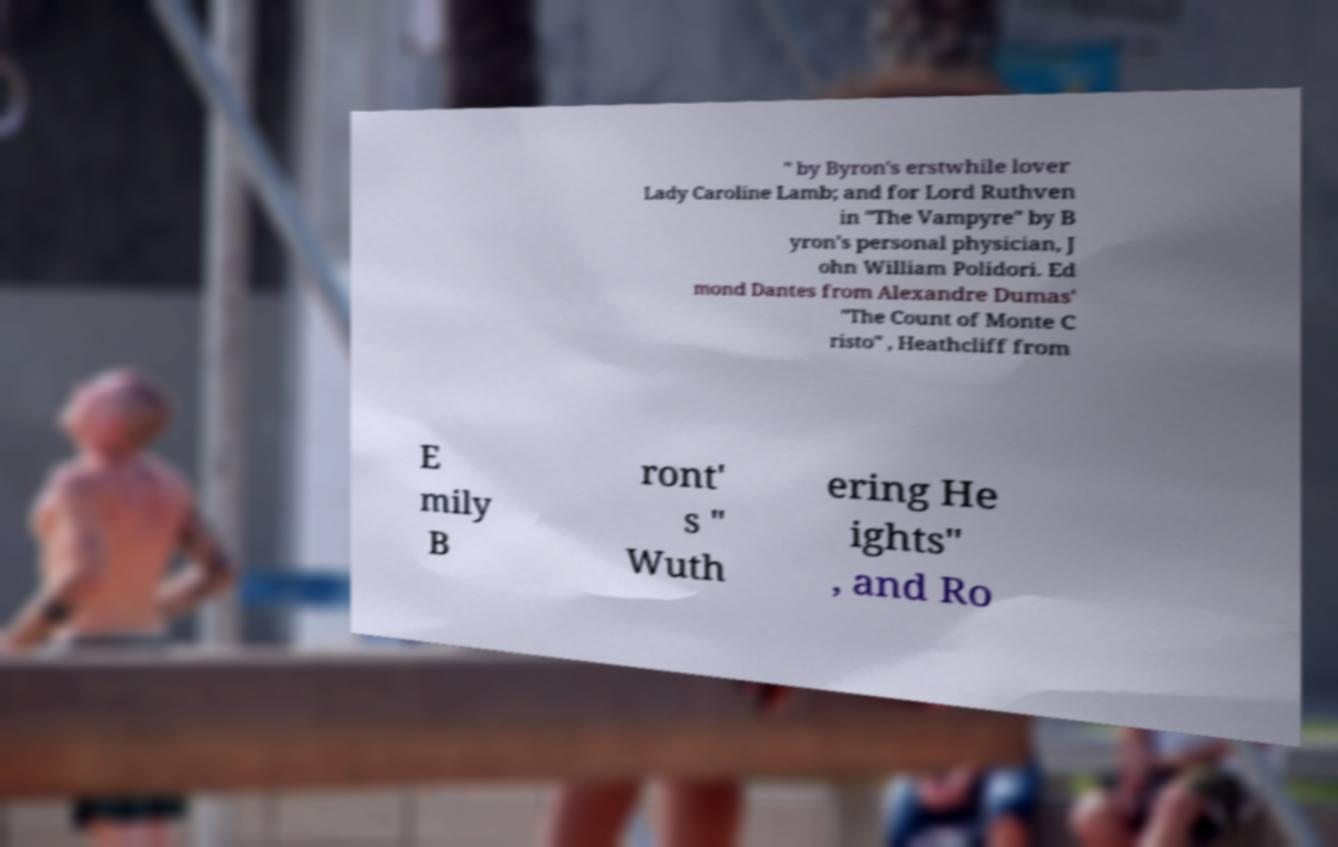Please read and relay the text visible in this image. What does it say? " by Byron's erstwhile lover Lady Caroline Lamb; and for Lord Ruthven in "The Vampyre" by B yron's personal physician, J ohn William Polidori. Ed mond Dantes from Alexandre Dumas' "The Count of Monte C risto" , Heathcliff from E mily B ront' s " Wuth ering He ights" , and Ro 